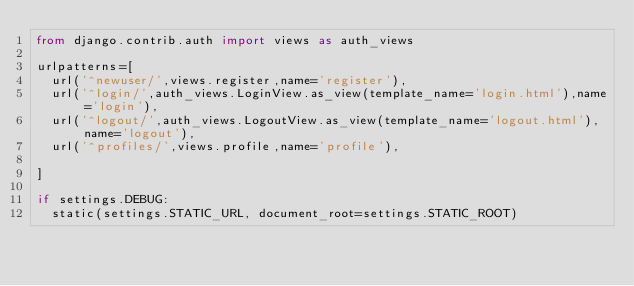Convert code to text. <code><loc_0><loc_0><loc_500><loc_500><_Python_>from django.contrib.auth import views as auth_views

urlpatterns=[
  url('^newuser/',views.register,name='register'),
  url('^login/',auth_views.LoginView.as_view(template_name='login.html'),name='login'),
  url('^logout/',auth_views.LogoutView.as_view(template_name='logout.html'),name='logout'),
  url('^profiles/',views.profile,name='profile'),

]

if settings.DEBUG:
  static(settings.STATIC_URL, document_root=settings.STATIC_ROOT)</code> 